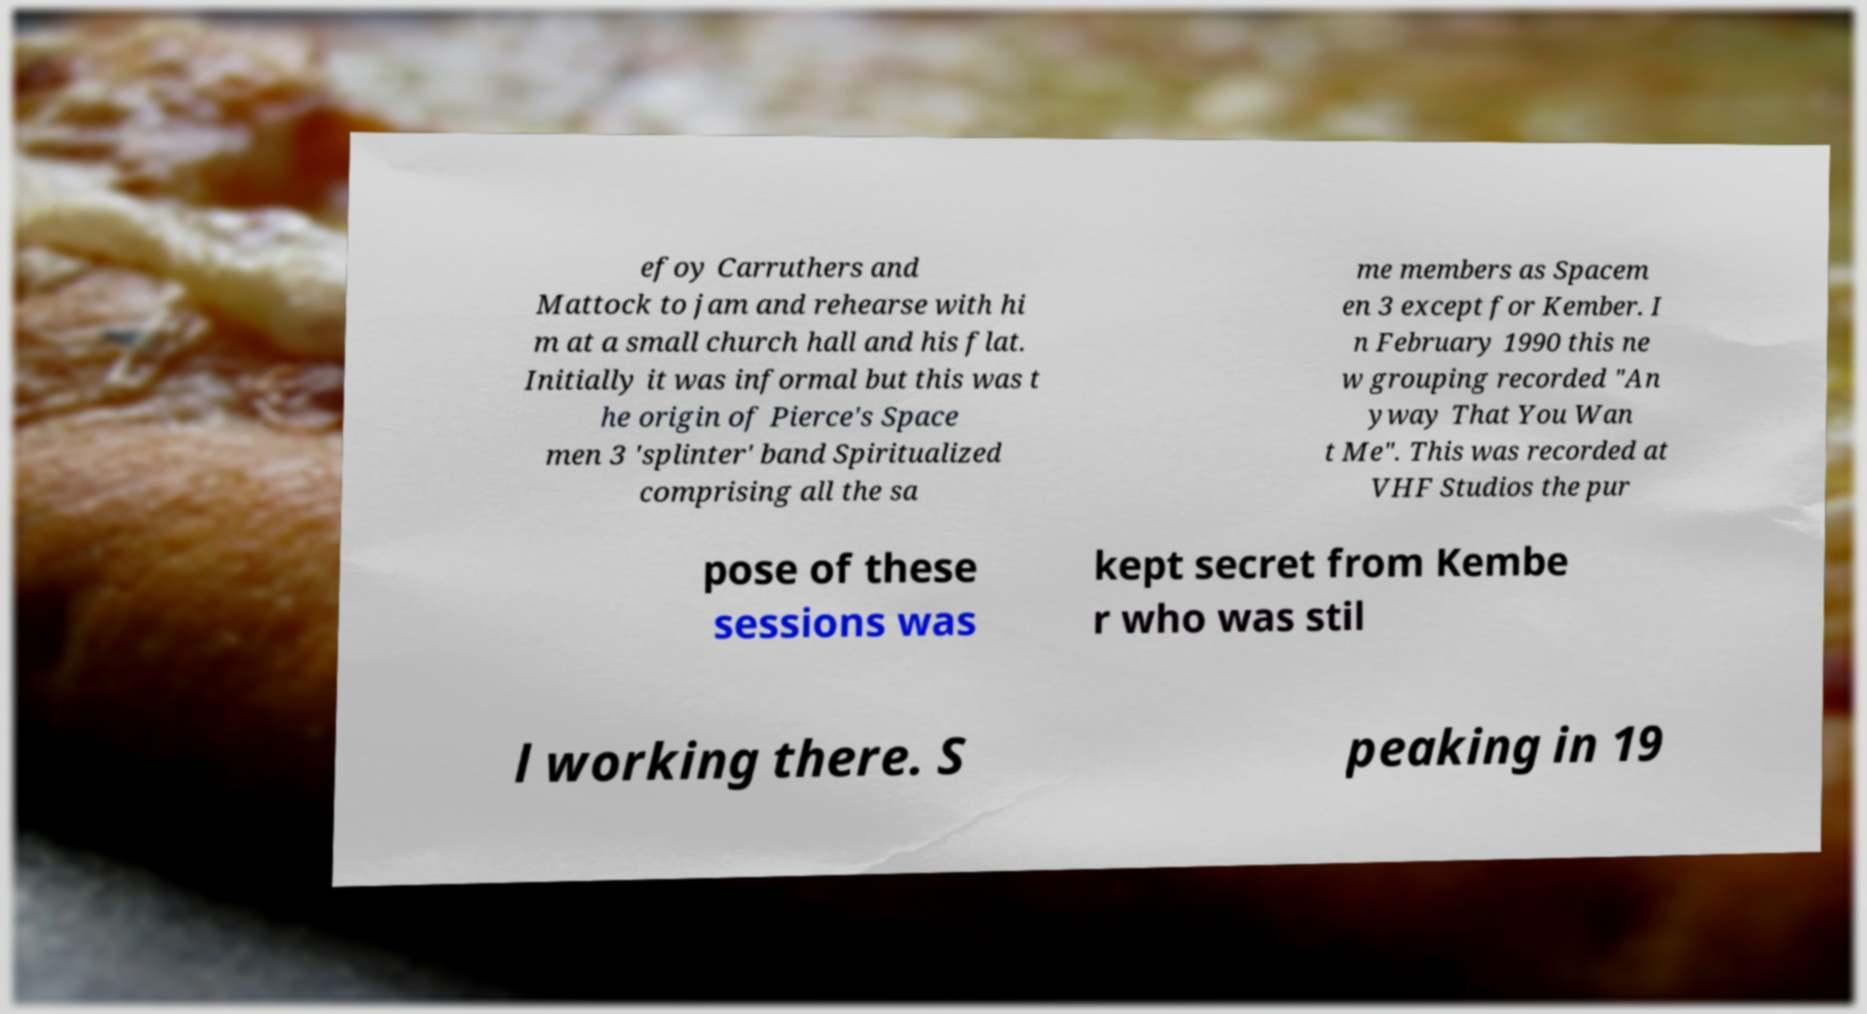What messages or text are displayed in this image? I need them in a readable, typed format. efoy Carruthers and Mattock to jam and rehearse with hi m at a small church hall and his flat. Initially it was informal but this was t he origin of Pierce's Space men 3 'splinter' band Spiritualized comprising all the sa me members as Spacem en 3 except for Kember. I n February 1990 this ne w grouping recorded "An yway That You Wan t Me". This was recorded at VHF Studios the pur pose of these sessions was kept secret from Kembe r who was stil l working there. S peaking in 19 